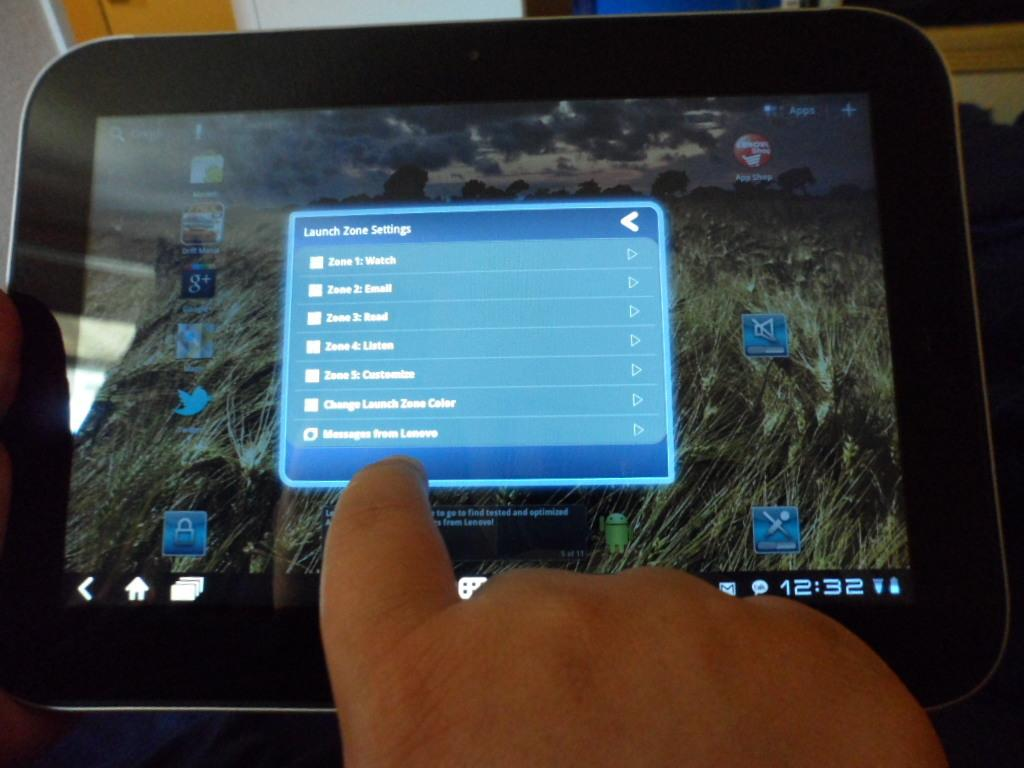What is the main subject in the foreground of the image? There is a screen of a tab in the foreground of the image. Can you describe any other elements in the image? A hand of a person is visible at the bottom of the image. How many deer can be seen grazing near the tree in the image? There are no deer or trees present in the image; it only features a screen of a tab and a hand. 